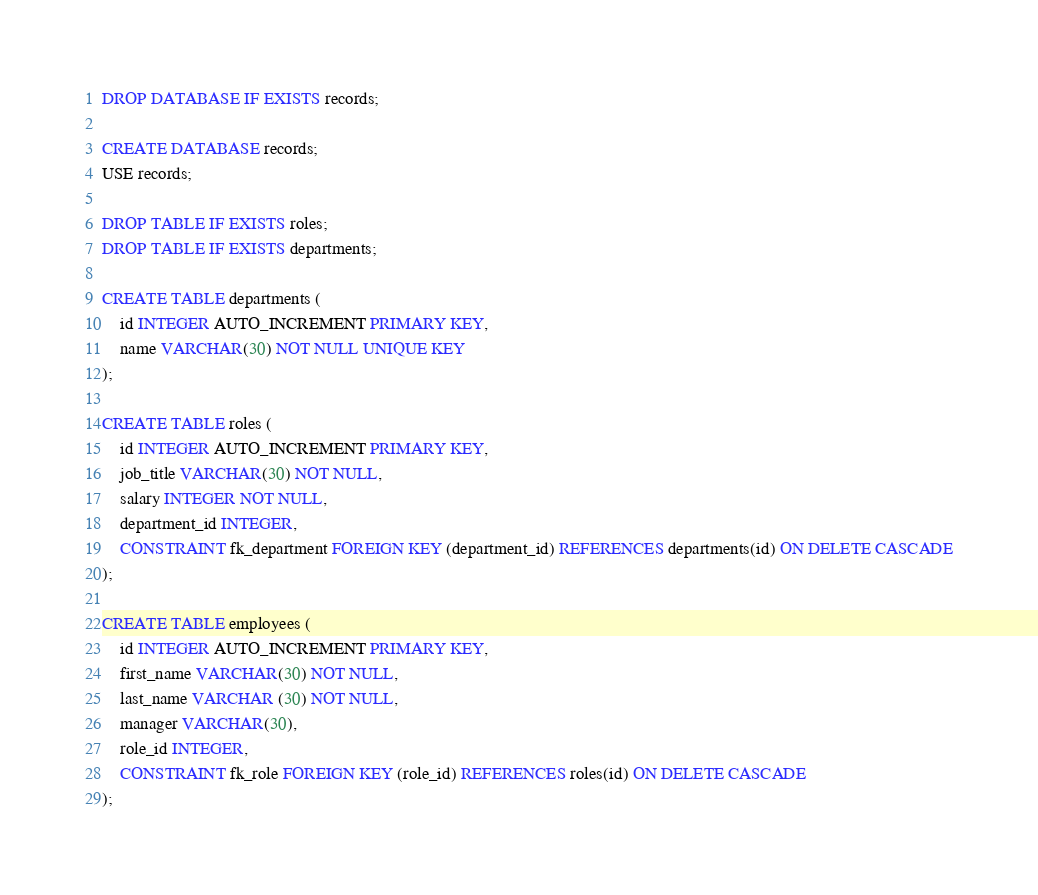Convert code to text. <code><loc_0><loc_0><loc_500><loc_500><_SQL_>DROP DATABASE IF EXISTS records;

CREATE DATABASE records;
USE records;

DROP TABLE IF EXISTS roles;
DROP TABLE IF EXISTS departments;

CREATE TABLE departments (
    id INTEGER AUTO_INCREMENT PRIMARY KEY,
    name VARCHAR(30) NOT NULL UNIQUE KEY
);

CREATE TABLE roles (
    id INTEGER AUTO_INCREMENT PRIMARY KEY,
    job_title VARCHAR(30) NOT NULL,
    salary INTEGER NOT NULL,
    department_id INTEGER,
    CONSTRAINT fk_department FOREIGN KEY (department_id) REFERENCES departments(id) ON DELETE CASCADE
);

CREATE TABLE employees (
    id INTEGER AUTO_INCREMENT PRIMARY KEY,
    first_name VARCHAR(30) NOT NULL,
    last_name VARCHAR (30) NOT NULL,
    manager VARCHAR(30),
    role_id INTEGER,
    CONSTRAINT fk_role FOREIGN KEY (role_id) REFERENCES roles(id) ON DELETE CASCADE
);

</code> 